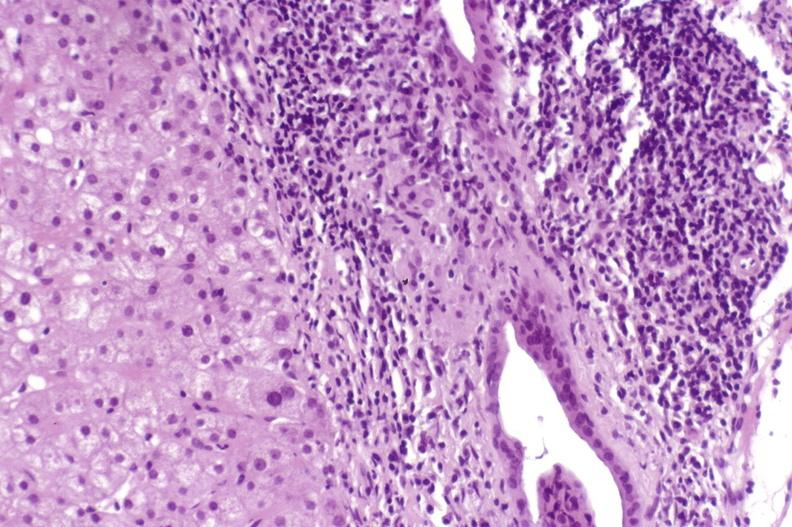does pinworm show primary biliary cirrhosis?
Answer the question using a single word or phrase. No 